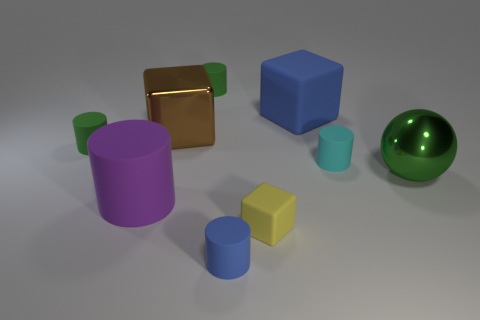Subtract all big blue cubes. How many cubes are left? 2 Subtract all blue cubes. How many green cylinders are left? 2 Add 1 large brown metallic objects. How many objects exist? 10 Subtract all purple cylinders. How many cylinders are left? 4 Subtract all blocks. How many objects are left? 6 Subtract all purple blocks. Subtract all green cylinders. How many blocks are left? 3 Add 5 tiny brown matte cylinders. How many tiny brown matte cylinders exist? 5 Subtract 0 green blocks. How many objects are left? 9 Subtract all big rubber objects. Subtract all large gray shiny cylinders. How many objects are left? 7 Add 2 green metallic spheres. How many green metallic spheres are left? 3 